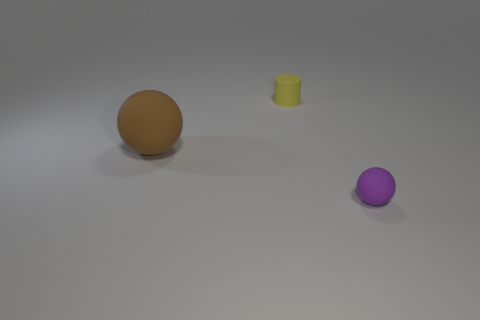Add 3 large brown matte balls. How many objects exist? 6 Subtract all balls. How many objects are left? 1 Subtract all brown balls. Subtract all purple objects. How many objects are left? 1 Add 2 large things. How many large things are left? 3 Add 1 big brown rubber spheres. How many big brown rubber spheres exist? 2 Subtract 0 yellow blocks. How many objects are left? 3 